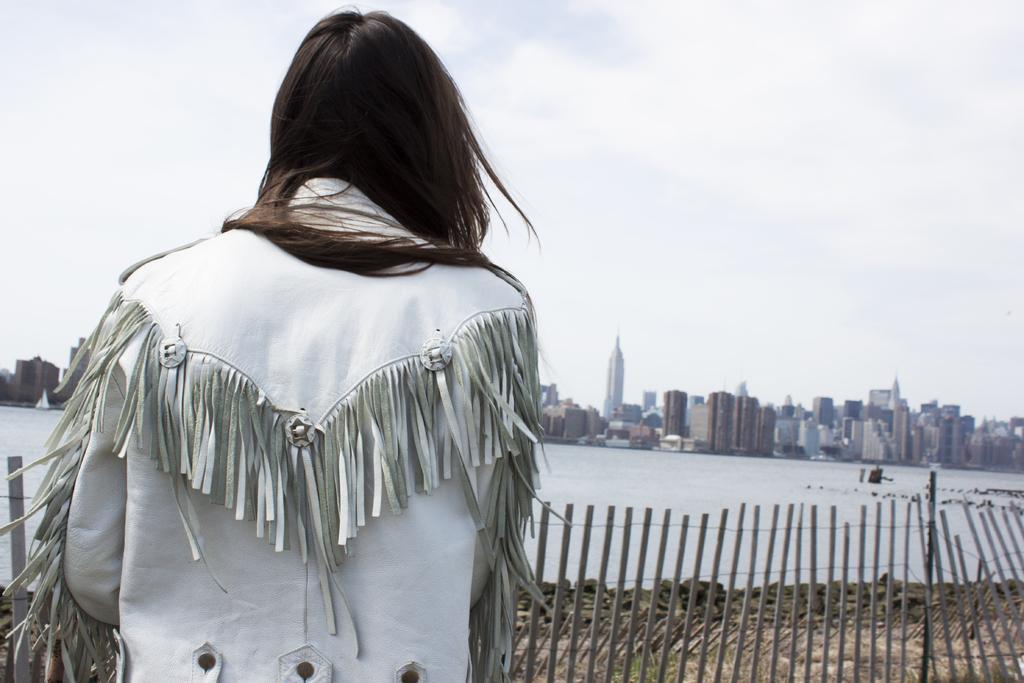In one or two sentences, can you explain what this image depicts? As we can see in the image in the front there is a person wearing white color dress and there is fence. In the background there are buildings. There is water and at the top there is sky. 